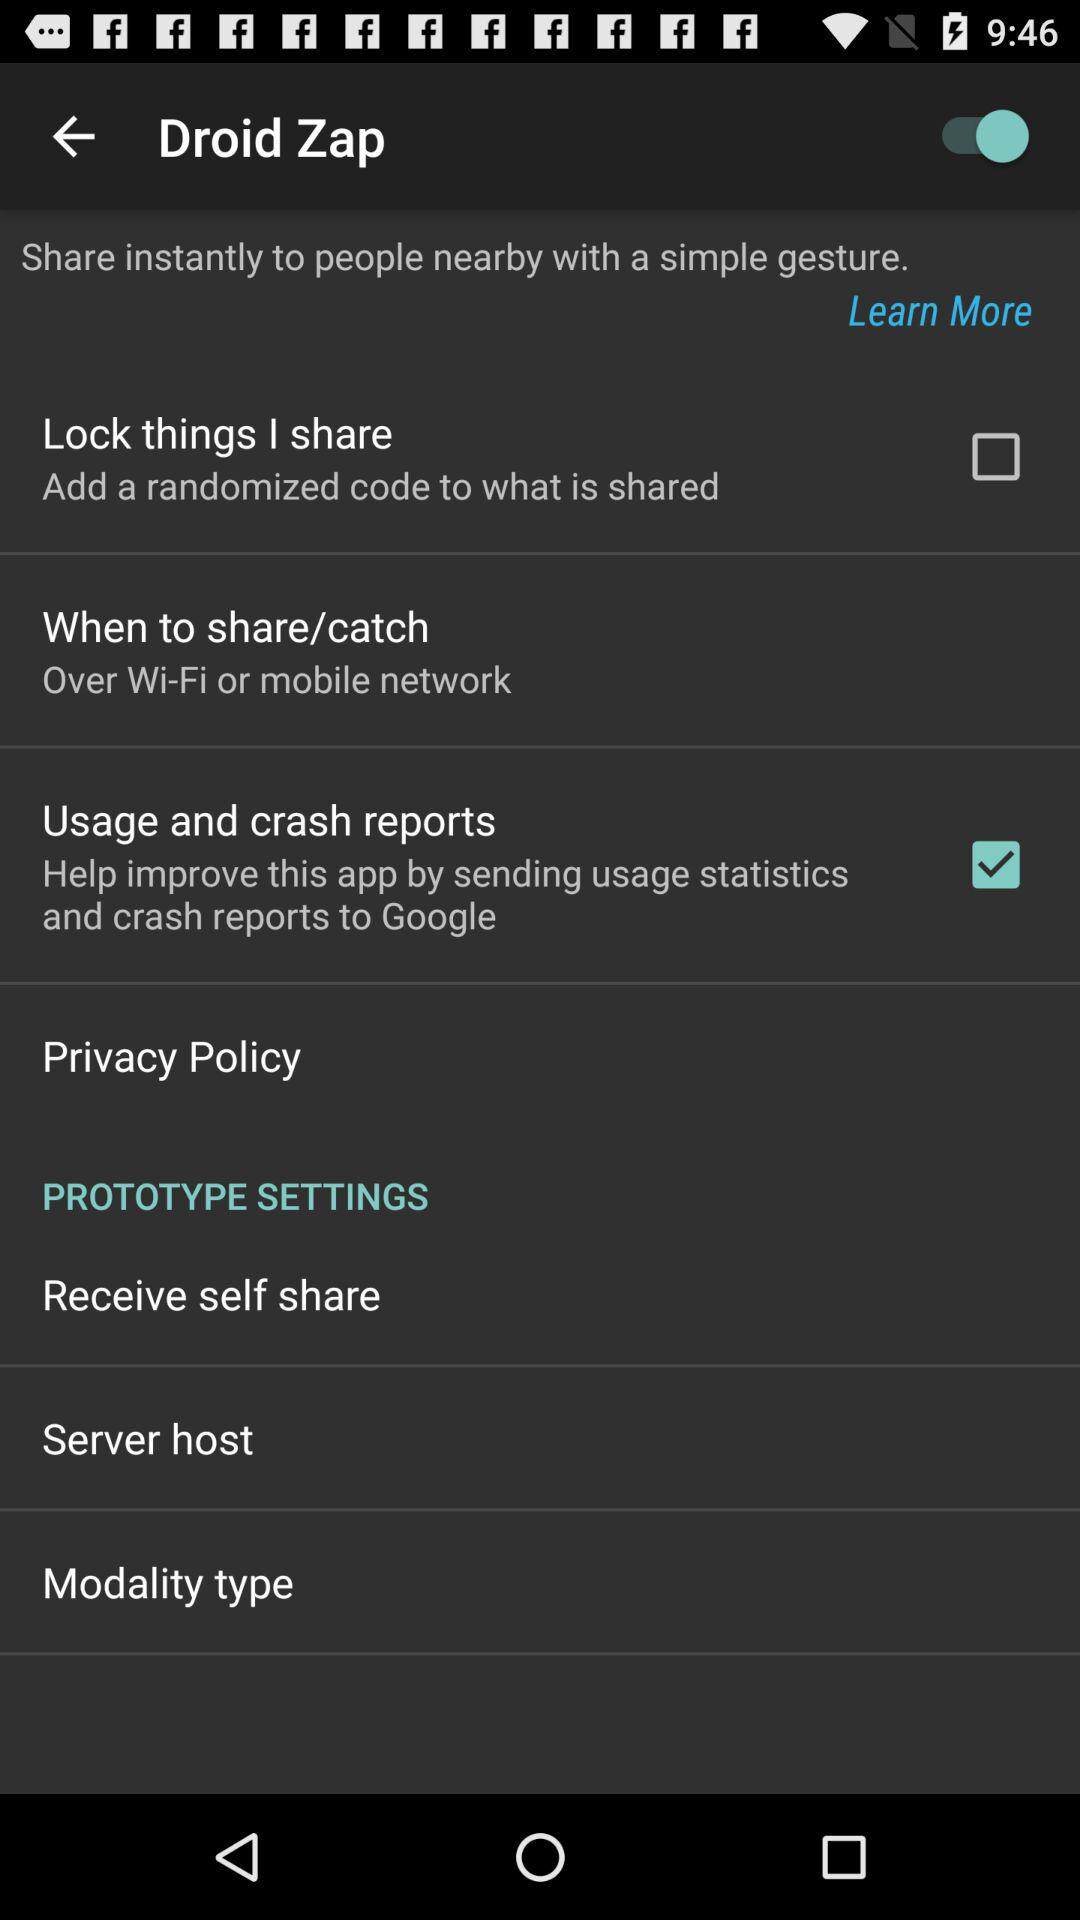What is the status of the "Droid Zap"? The status of the "Droid Zap" is "on". 